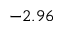Convert formula to latex. <formula><loc_0><loc_0><loc_500><loc_500>- 2 . 9 6</formula> 